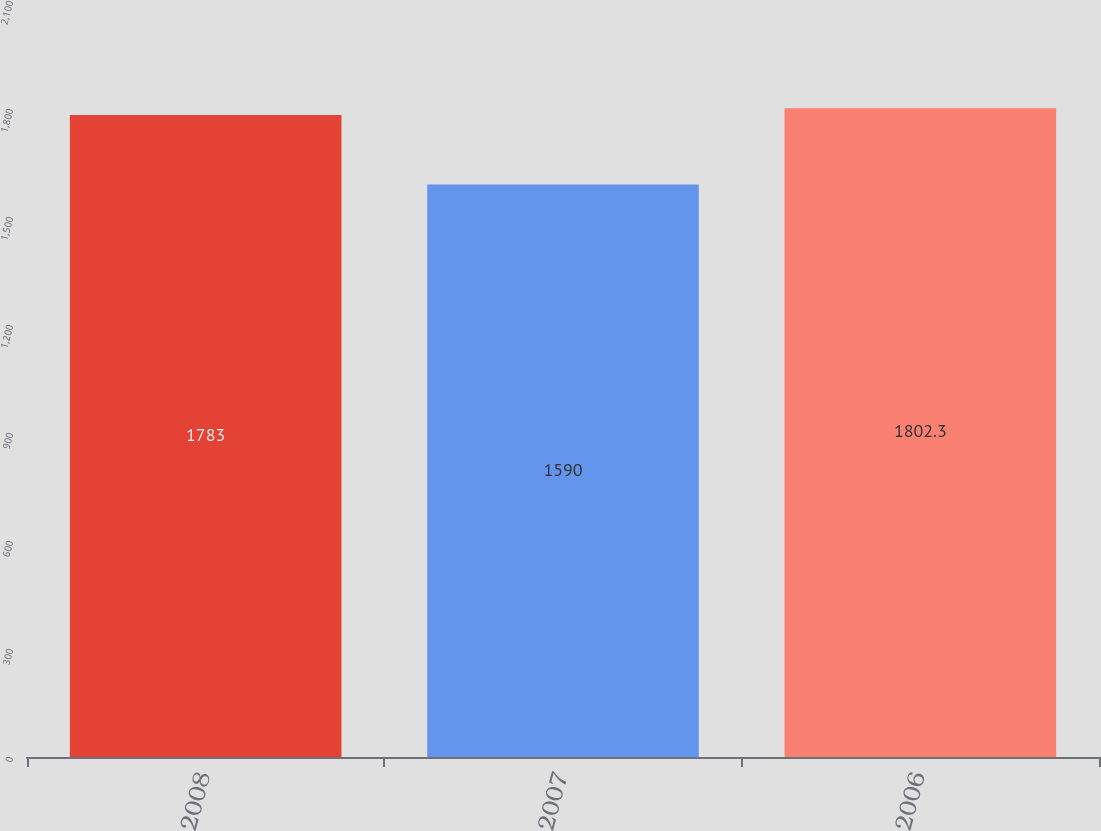Convert chart to OTSL. <chart><loc_0><loc_0><loc_500><loc_500><bar_chart><fcel>2008<fcel>2007<fcel>2006<nl><fcel>1783<fcel>1590<fcel>1802.3<nl></chart> 